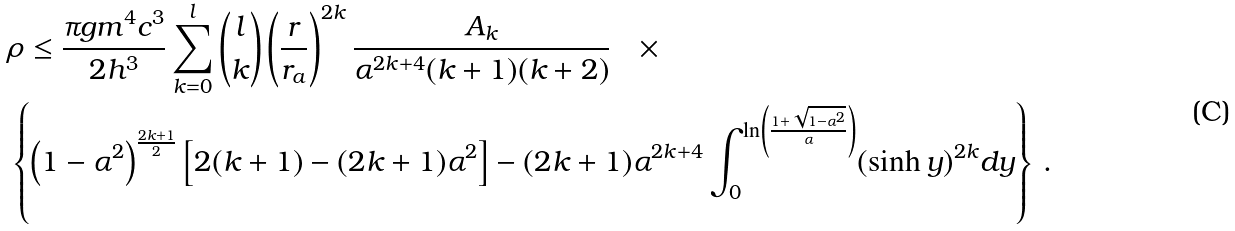<formula> <loc_0><loc_0><loc_500><loc_500>& \rho \leq \frac { \pi g m ^ { 4 } c ^ { 3 } } { 2 h ^ { 3 } } \sum _ { k = 0 } ^ { l } \binom { l } { k } \left ( \frac { r } { r _ { a } } \right ) ^ { 2 k } \frac { A _ { k } } { \alpha ^ { 2 k + 4 } ( k + 1 ) ( k + 2 ) } \quad \times \\ & \left \{ \left ( 1 - \alpha ^ { 2 } \right ) ^ { \frac { 2 k + 1 } { 2 } } \left [ 2 ( k + 1 ) - ( 2 k + 1 ) \alpha ^ { 2 } \right ] - ( 2 k + 1 ) \alpha ^ { 2 k + 4 } \int _ { 0 } ^ { \ln \left ( \frac { 1 + \sqrt { 1 - \alpha ^ { 2 } } } { \alpha } \right ) } ( \sinh y ) ^ { 2 k } d y \right \} \, .</formula> 